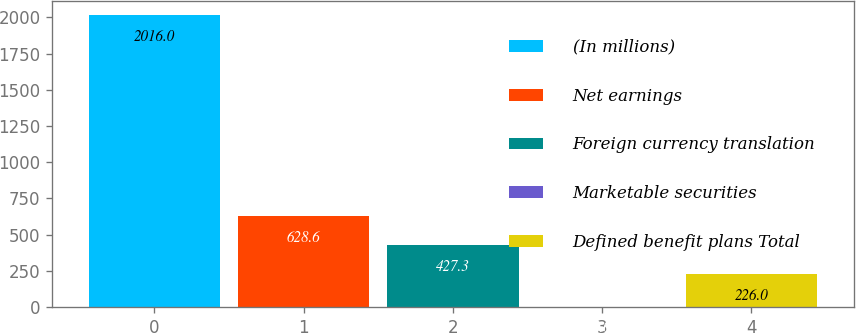Convert chart to OTSL. <chart><loc_0><loc_0><loc_500><loc_500><bar_chart><fcel>(In millions)<fcel>Net earnings<fcel>Foreign currency translation<fcel>Marketable securities<fcel>Defined benefit plans Total<nl><fcel>2016<fcel>628.6<fcel>427.3<fcel>3<fcel>226<nl></chart> 